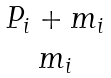<formula> <loc_0><loc_0><loc_500><loc_500>\begin{matrix} P _ { i } + m _ { i } \\ m _ { i } \\ \end{matrix}</formula> 